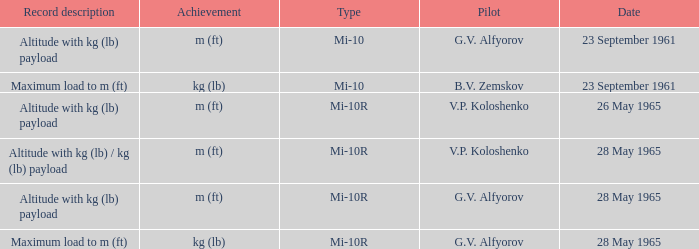Pilot of g.v. alfyorov, and a Record description of altitude with kg (lb) payload, and a Type of mi-10 involved what date? 23 September 1961. 